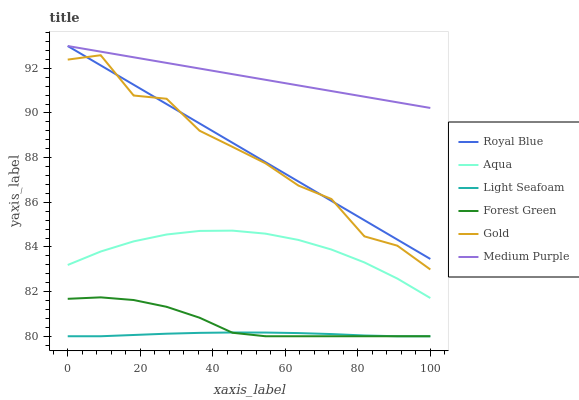Does Light Seafoam have the minimum area under the curve?
Answer yes or no. Yes. Does Medium Purple have the maximum area under the curve?
Answer yes or no. Yes. Does Aqua have the minimum area under the curve?
Answer yes or no. No. Does Aqua have the maximum area under the curve?
Answer yes or no. No. Is Medium Purple the smoothest?
Answer yes or no. Yes. Is Gold the roughest?
Answer yes or no. Yes. Is Aqua the smoothest?
Answer yes or no. No. Is Aqua the roughest?
Answer yes or no. No. Does Forest Green have the lowest value?
Answer yes or no. Yes. Does Aqua have the lowest value?
Answer yes or no. No. Does Royal Blue have the highest value?
Answer yes or no. Yes. Does Aqua have the highest value?
Answer yes or no. No. Is Aqua less than Royal Blue?
Answer yes or no. Yes. Is Royal Blue greater than Aqua?
Answer yes or no. Yes. Does Royal Blue intersect Gold?
Answer yes or no. Yes. Is Royal Blue less than Gold?
Answer yes or no. No. Is Royal Blue greater than Gold?
Answer yes or no. No. Does Aqua intersect Royal Blue?
Answer yes or no. No. 